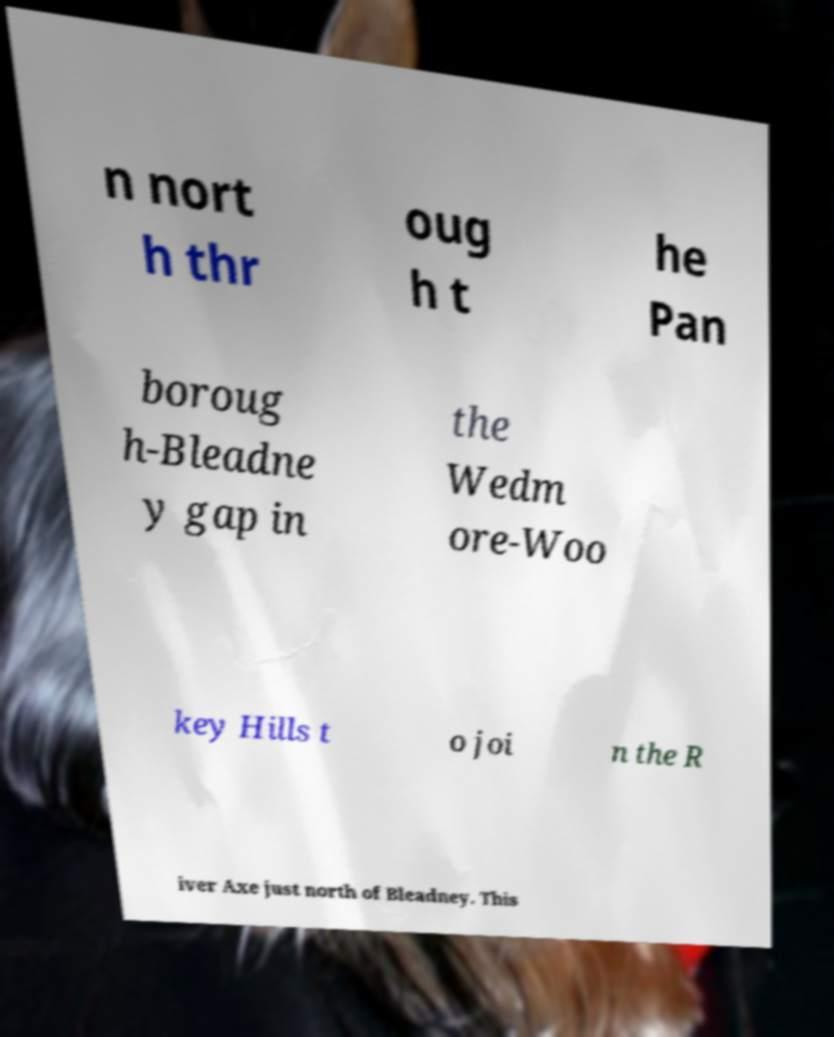What messages or text are displayed in this image? I need them in a readable, typed format. n nort h thr oug h t he Pan boroug h-Bleadne y gap in the Wedm ore-Woo key Hills t o joi n the R iver Axe just north of Bleadney. This 